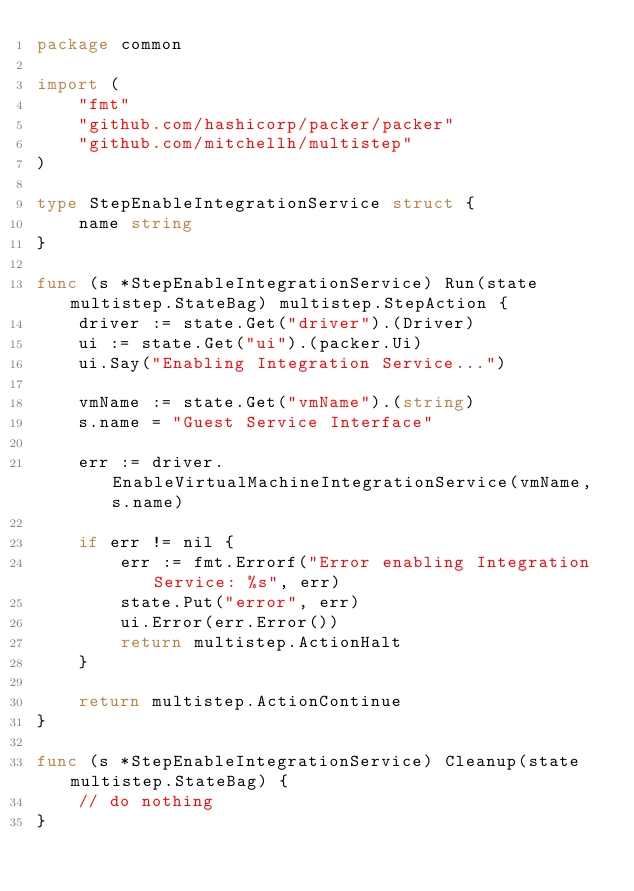<code> <loc_0><loc_0><loc_500><loc_500><_Go_>package common

import (
	"fmt"
	"github.com/hashicorp/packer/packer"
	"github.com/mitchellh/multistep"
)

type StepEnableIntegrationService struct {
	name string
}

func (s *StepEnableIntegrationService) Run(state multistep.StateBag) multistep.StepAction {
	driver := state.Get("driver").(Driver)
	ui := state.Get("ui").(packer.Ui)
	ui.Say("Enabling Integration Service...")

	vmName := state.Get("vmName").(string)
	s.name = "Guest Service Interface"

	err := driver.EnableVirtualMachineIntegrationService(vmName, s.name)

	if err != nil {
		err := fmt.Errorf("Error enabling Integration Service: %s", err)
		state.Put("error", err)
		ui.Error(err.Error())
		return multistep.ActionHalt
	}

	return multistep.ActionContinue
}

func (s *StepEnableIntegrationService) Cleanup(state multistep.StateBag) {
	// do nothing
}
</code> 